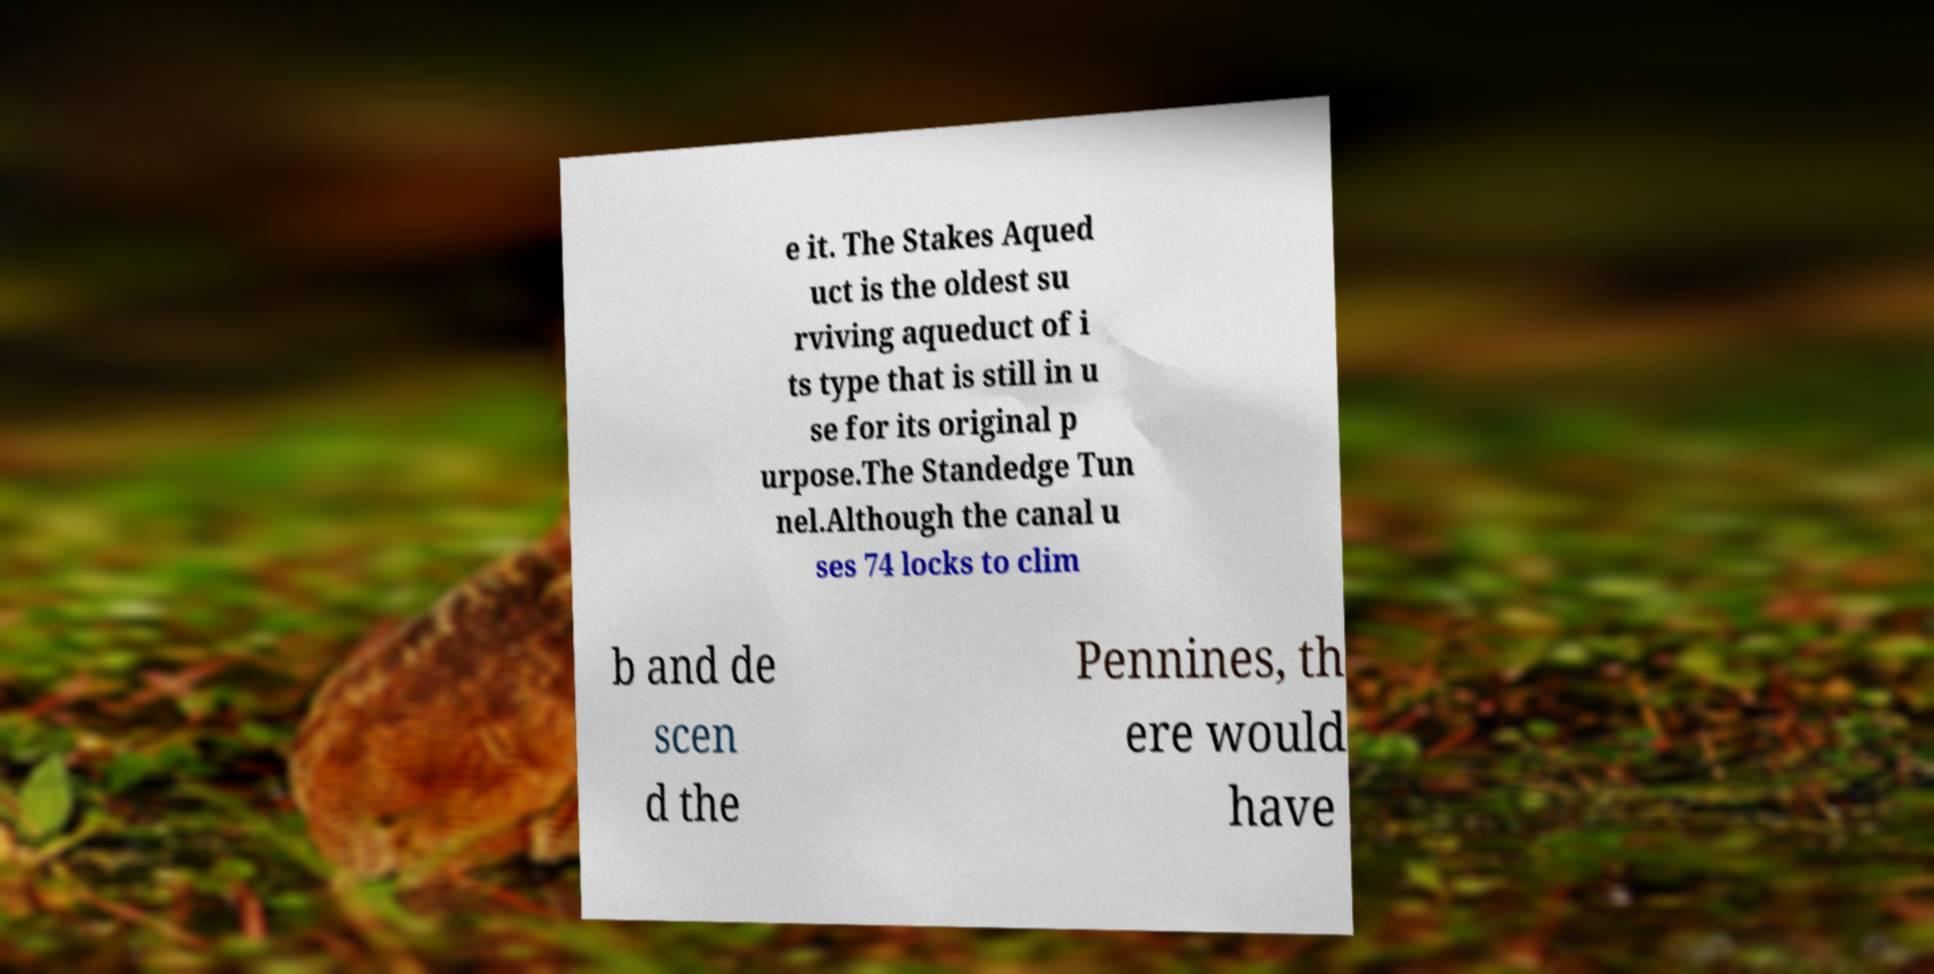Could you extract and type out the text from this image? e it. The Stakes Aqued uct is the oldest su rviving aqueduct of i ts type that is still in u se for its original p urpose.The Standedge Tun nel.Although the canal u ses 74 locks to clim b and de scen d the Pennines, th ere would have 